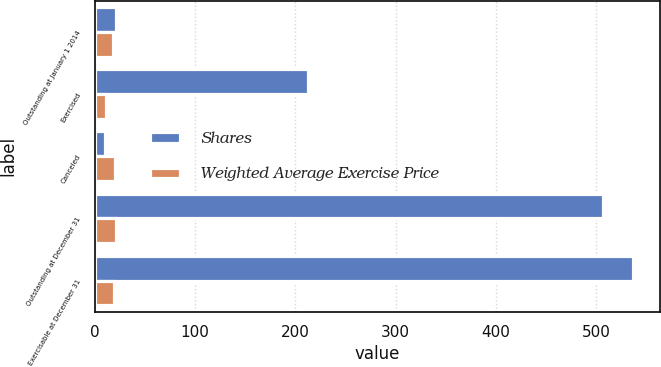Convert chart to OTSL. <chart><loc_0><loc_0><loc_500><loc_500><stacked_bar_chart><ecel><fcel>Outstanding at January 1 2014<fcel>Exercised<fcel>Canceled<fcel>Outstanding at December 31<fcel>Exercisable at December 31<nl><fcel>Shares<fcel>20.99<fcel>213<fcel>10<fcel>507<fcel>537<nl><fcel>Weighted Average Exercise Price<fcel>17.85<fcel>11.21<fcel>19.98<fcel>21.37<fcel>19.49<nl></chart> 